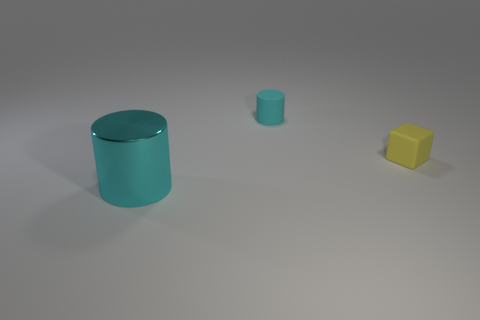Add 2 tiny cyan rubber cylinders. How many objects exist? 5 Subtract all cylinders. How many objects are left? 1 Add 3 tiny blocks. How many tiny blocks are left? 4 Add 3 rubber things. How many rubber things exist? 5 Subtract 1 cyan cylinders. How many objects are left? 2 Subtract all purple spheres. Subtract all large cylinders. How many objects are left? 2 